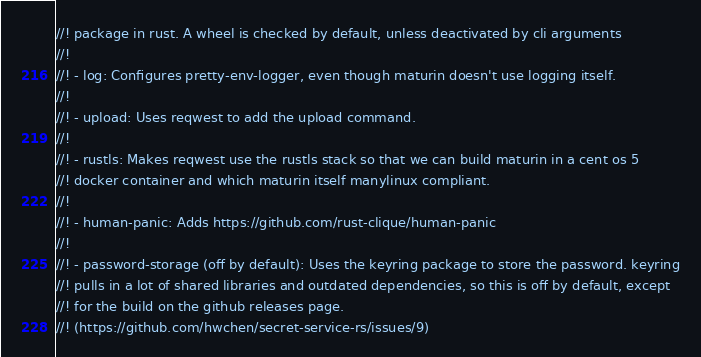<code> <loc_0><loc_0><loc_500><loc_500><_Rust_>//! package in rust. A wheel is checked by default, unless deactivated by cli arguments
//!
//! - log: Configures pretty-env-logger, even though maturin doesn't use logging itself.
//!
//! - upload: Uses reqwest to add the upload command.
//!
//! - rustls: Makes reqwest use the rustls stack so that we can build maturin in a cent os 5
//! docker container and which maturin itself manylinux compliant.
//!
//! - human-panic: Adds https://github.com/rust-clique/human-panic
//!
//! - password-storage (off by default): Uses the keyring package to store the password. keyring
//! pulls in a lot of shared libraries and outdated dependencies, so this is off by default, except
//! for the build on the github releases page.
//! (https://github.com/hwchen/secret-service-rs/issues/9)
</code> 